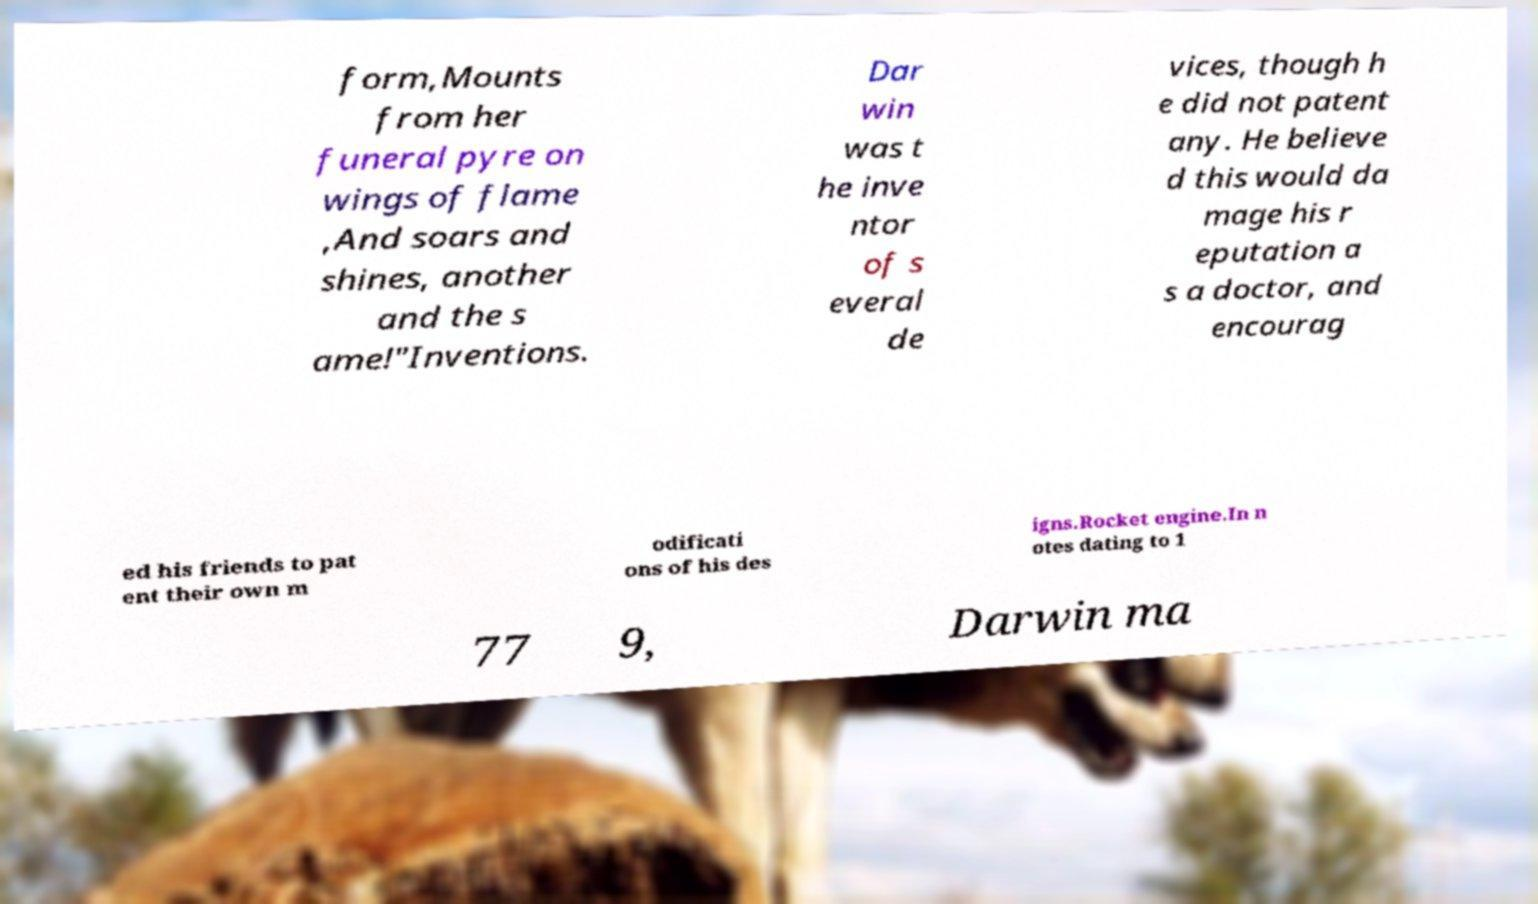For documentation purposes, I need the text within this image transcribed. Could you provide that? form,Mounts from her funeral pyre on wings of flame ,And soars and shines, another and the s ame!"Inventions. Dar win was t he inve ntor of s everal de vices, though h e did not patent any. He believe d this would da mage his r eputation a s a doctor, and encourag ed his friends to pat ent their own m odificati ons of his des igns.Rocket engine.In n otes dating to 1 77 9, Darwin ma 